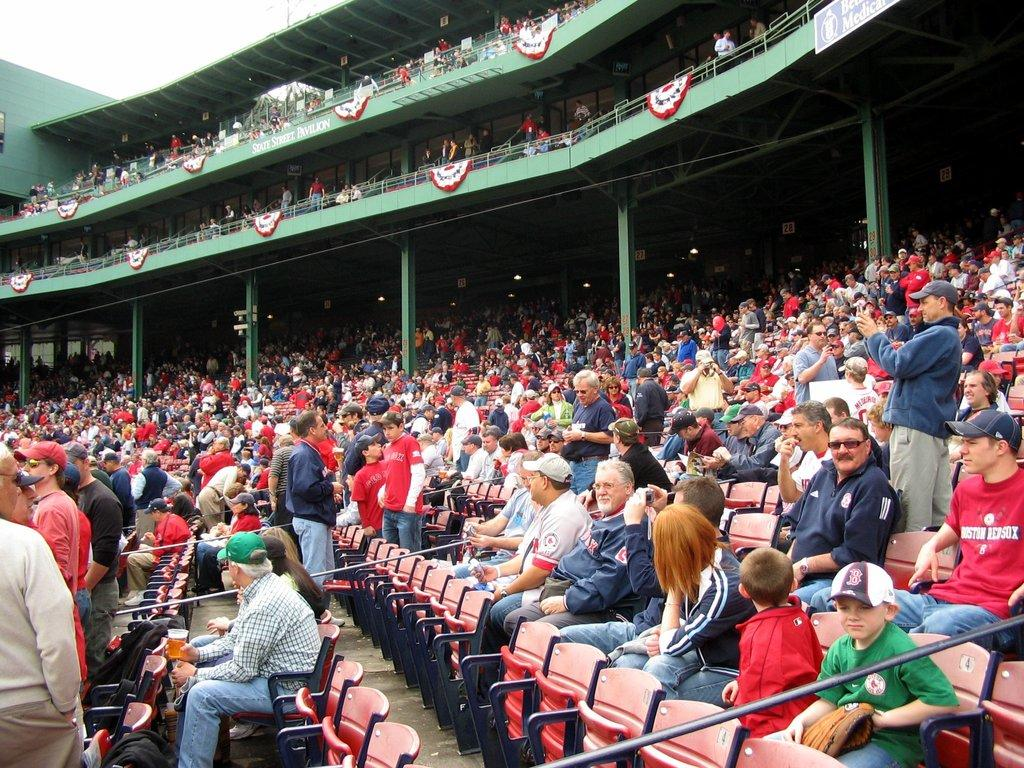What can be seen in the image? There is an audience in the image, with some members sitting on chairs and others standing. What architectural features are present in the image? There are railings, pillars, and hoardings in the image. What is visible in the background of the image? The sky is visible in the image. What else can be seen in the image? There are objects in the image. What type of calendar is hanging on the canvas in the image? There is no calendar or canvas present in the image. 